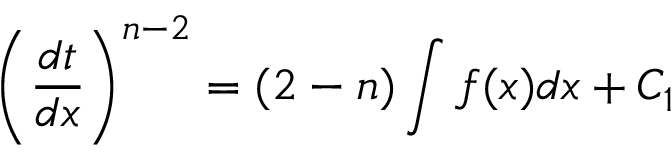<formula> <loc_0><loc_0><loc_500><loc_500>\left ( { \frac { d t } { d x } } \right ) ^ { n - 2 } = ( 2 - n ) \int f ( x ) d x + C _ { 1 }</formula> 